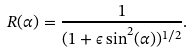<formula> <loc_0><loc_0><loc_500><loc_500>R ( \alpha ) = \frac { 1 } { ( 1 + \epsilon \sin ^ { 2 } ( \alpha ) ) ^ { 1 / 2 } } .</formula> 